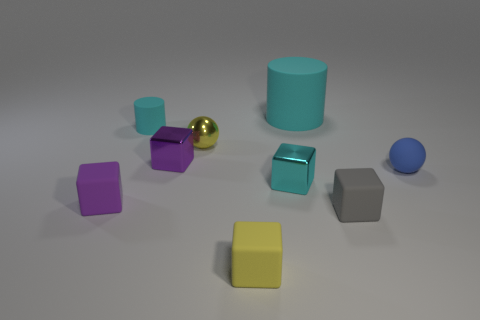Subtract 1 cubes. How many cubes are left? 4 Add 1 big yellow shiny spheres. How many objects exist? 10 Subtract all small purple rubber cubes. How many cubes are left? 4 Subtract all yellow blocks. How many blocks are left? 4 Subtract all gray cubes. Subtract all brown cylinders. How many cubes are left? 4 Subtract all cylinders. How many objects are left? 7 Subtract all cyan rubber cubes. Subtract all small cyan matte cylinders. How many objects are left? 8 Add 1 purple things. How many purple things are left? 3 Add 7 tiny gray blocks. How many tiny gray blocks exist? 8 Subtract 0 green blocks. How many objects are left? 9 